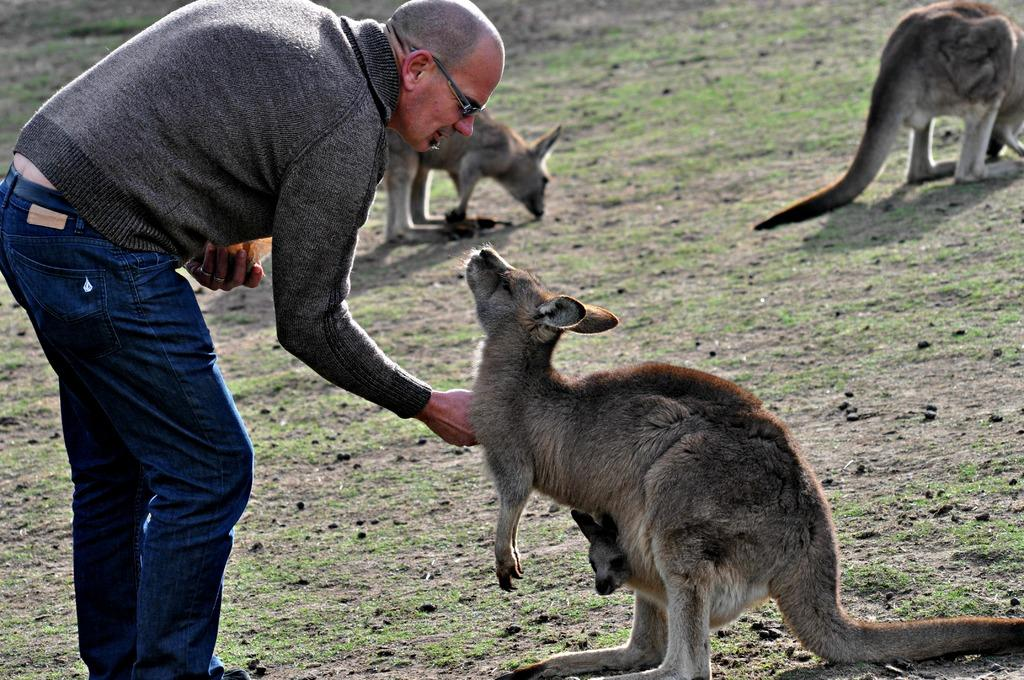How many kangaroos are in the image? There are three kangaroos in the image. What else is present in the image besides the kangaroos? There is a man in the image. What is the man doing in the image? The man appears to be feeding the kangaroos. What type of surface can be seen at the bottom of the image? There is ground visible at the bottom of the image. Can you tell me how many visitors are in the image? There is no mention of visitors in the image; it features a man feeding three kangaroos. What type of bun is on the kangaroo's nose in the image? There are no buns or any other objects on the kangaroos' noses in the image. 